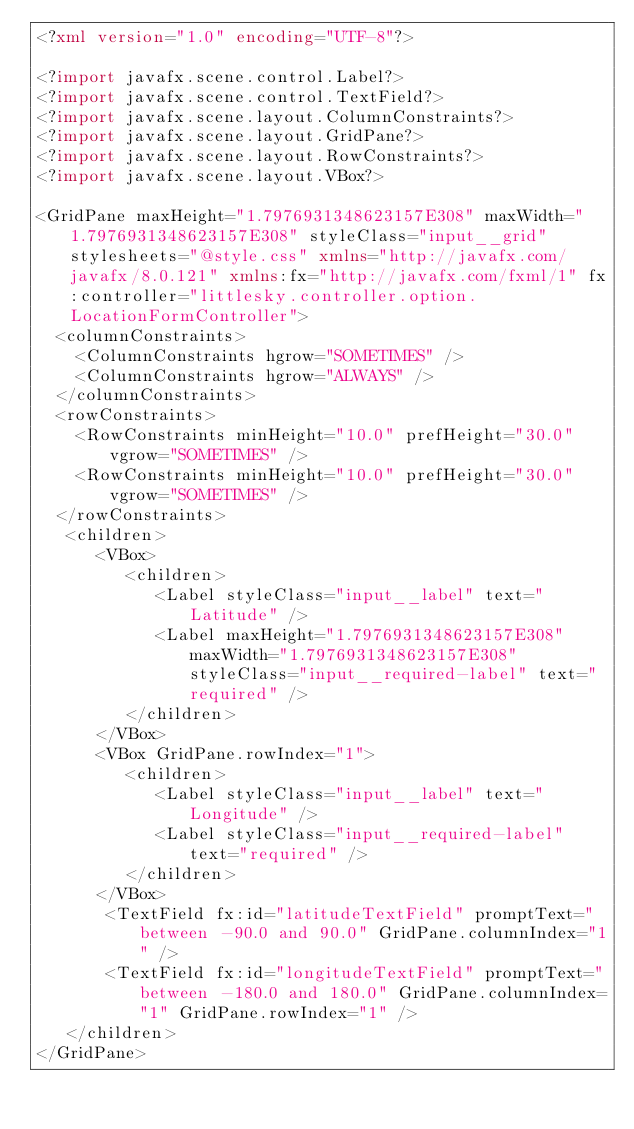<code> <loc_0><loc_0><loc_500><loc_500><_XML_><?xml version="1.0" encoding="UTF-8"?>

<?import javafx.scene.control.Label?>
<?import javafx.scene.control.TextField?>
<?import javafx.scene.layout.ColumnConstraints?>
<?import javafx.scene.layout.GridPane?>
<?import javafx.scene.layout.RowConstraints?>
<?import javafx.scene.layout.VBox?>

<GridPane maxHeight="1.7976931348623157E308" maxWidth="1.7976931348623157E308" styleClass="input__grid" stylesheets="@style.css" xmlns="http://javafx.com/javafx/8.0.121" xmlns:fx="http://javafx.com/fxml/1" fx:controller="littlesky.controller.option.LocationFormController">
  <columnConstraints>
    <ColumnConstraints hgrow="SOMETIMES" />
    <ColumnConstraints hgrow="ALWAYS" />
  </columnConstraints>
  <rowConstraints>
    <RowConstraints minHeight="10.0" prefHeight="30.0" vgrow="SOMETIMES" />
    <RowConstraints minHeight="10.0" prefHeight="30.0" vgrow="SOMETIMES" />
  </rowConstraints>
   <children>
      <VBox>
         <children>
            <Label styleClass="input__label" text="Latitude" />
            <Label maxHeight="1.7976931348623157E308" maxWidth="1.7976931348623157E308" styleClass="input__required-label" text="required" />
         </children>
      </VBox>
      <VBox GridPane.rowIndex="1">
         <children>
            <Label styleClass="input__label" text="Longitude" />
            <Label styleClass="input__required-label" text="required" />
         </children>
      </VBox>
       <TextField fx:id="latitudeTextField" promptText="between -90.0 and 90.0" GridPane.columnIndex="1" />
       <TextField fx:id="longitudeTextField" promptText="between -180.0 and 180.0" GridPane.columnIndex="1" GridPane.rowIndex="1" />
   </children>
</GridPane>
</code> 